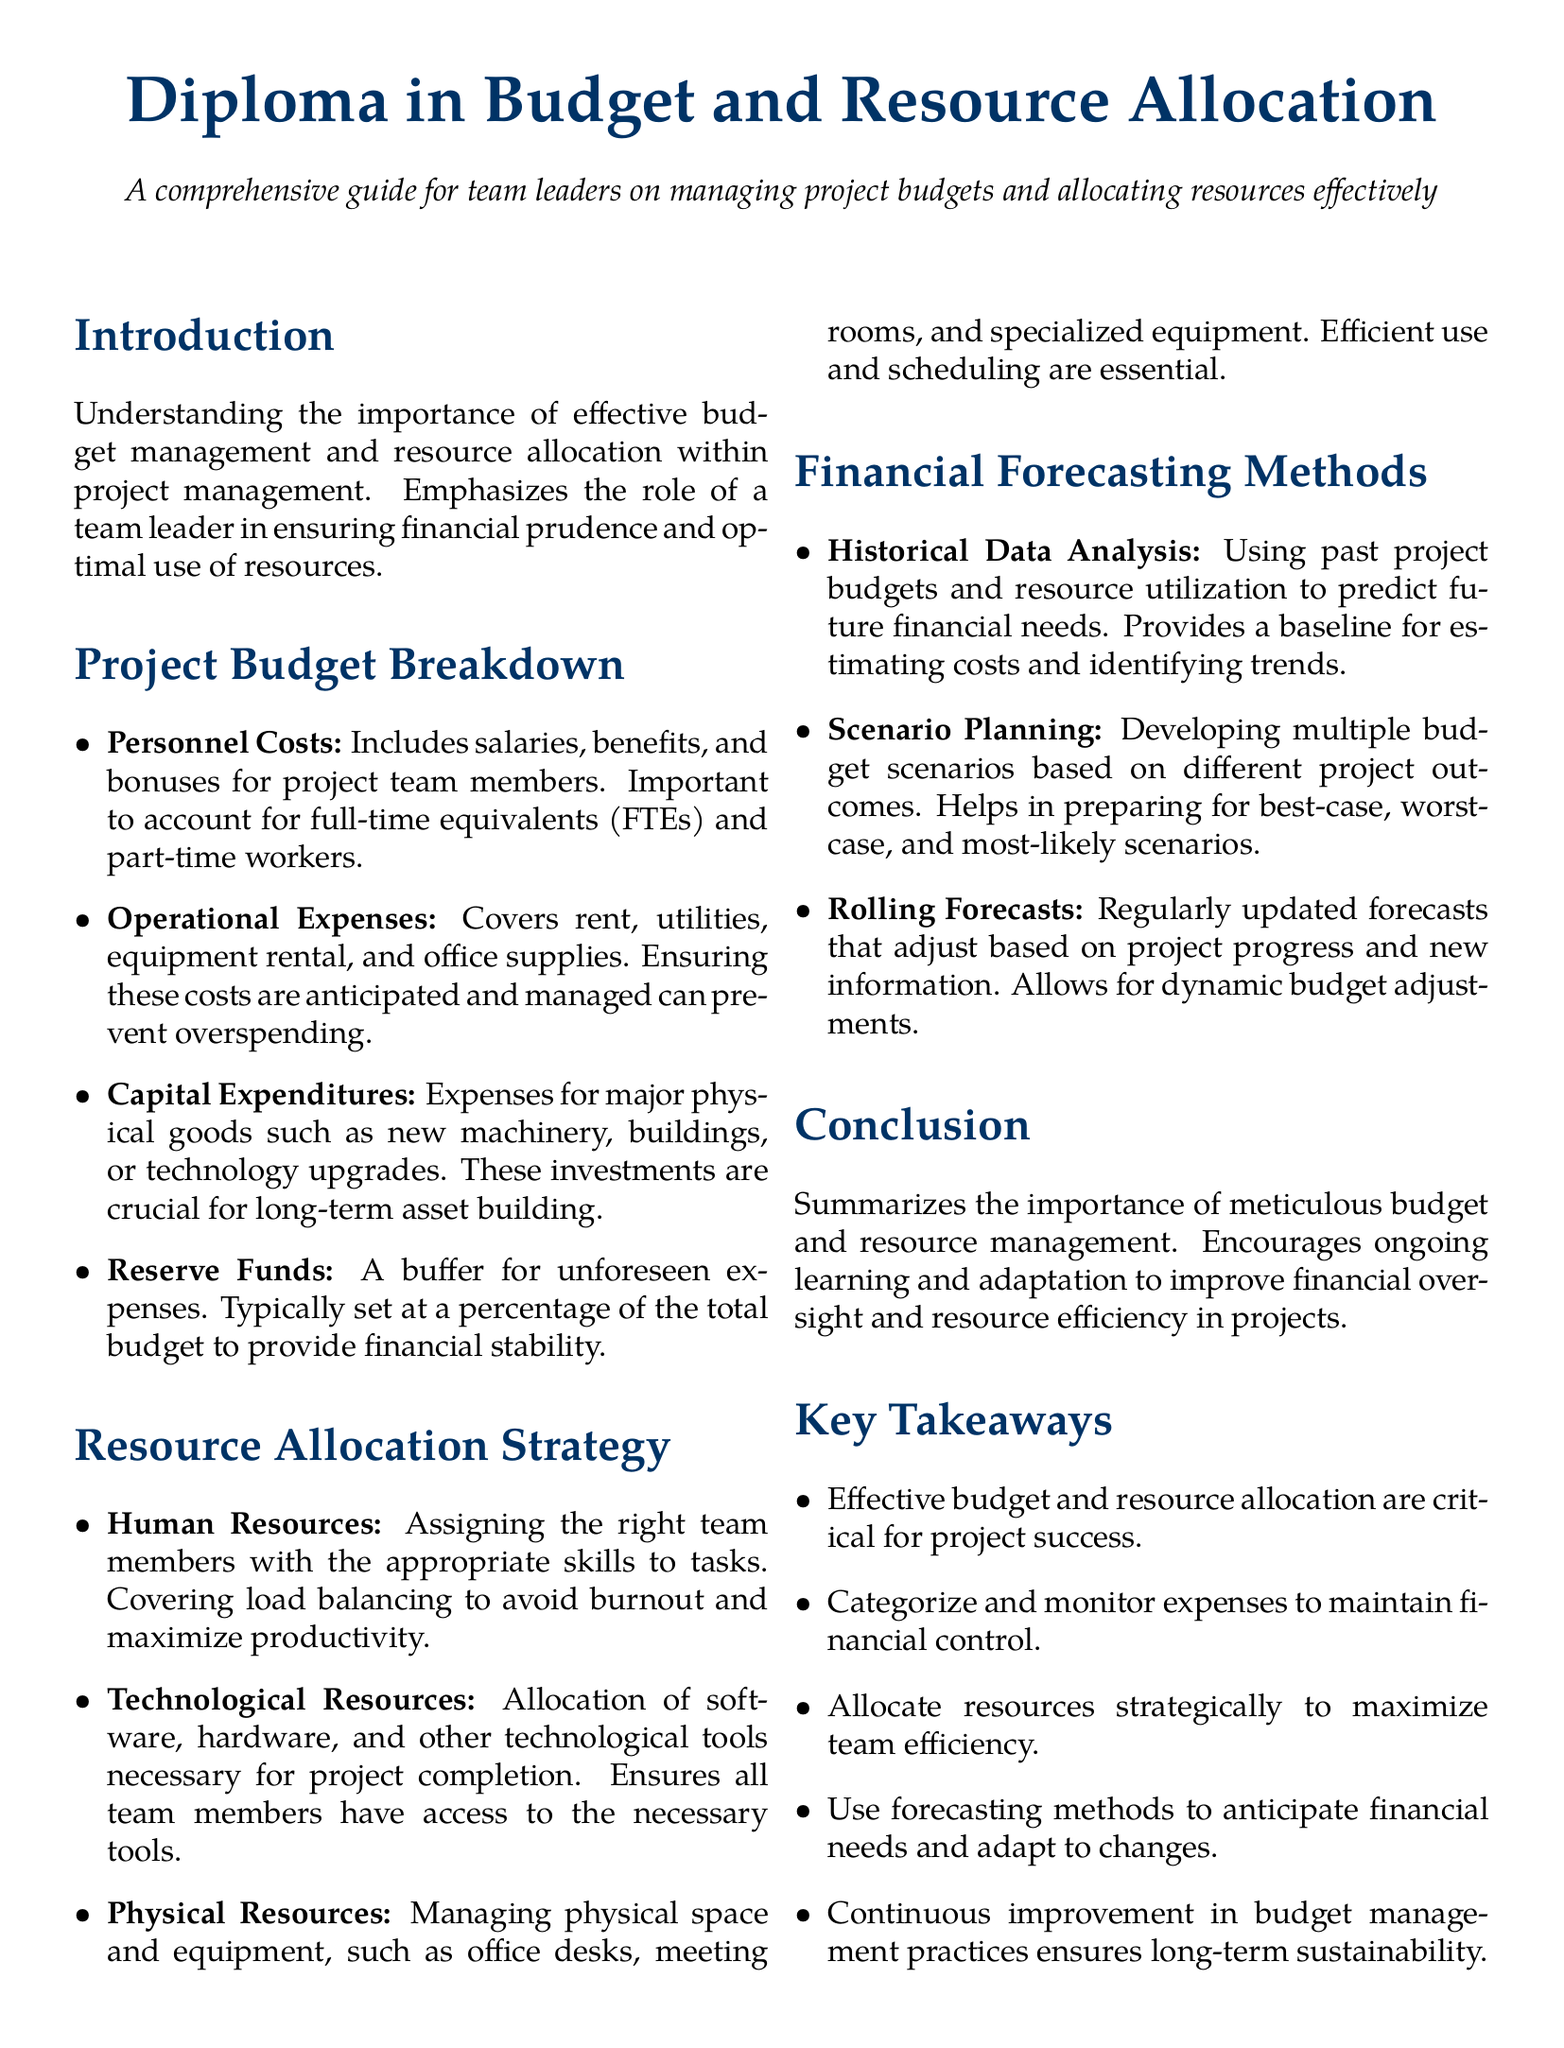What is the title of the diploma? The title of the diploma is presented prominently at the beginning of the document.
Answer: Diploma in Budget and Resource Allocation What are the main categories of expenses in the project budget? The categories of expenses in the project budget are listed in the Project Budget Breakdown section.
Answer: Personnel Costs, Operational Expenses, Capital Expenditures, Reserve Funds What does "FTE" stand for? The term "FTE" is used in the context of Personnel Costs to refer to a specific measure of full-time work.
Answer: Full-Time Equivalent What is a method mentioned for financial forecasting? The document lists various methods for financial forecasting under a dedicated section.
Answer: Historical Data Analysis What is the primary goal of resource allocation? The main goal is to ensure effective use of team capabilities and resources, as described in the Resource Allocation Strategy.
Answer: Maximize productivity What does scenario planning involve? Scenario planning as mentioned in the document involves preparing for various project outcomes.
Answer: Developing multiple budget scenarios Who is the diploma intended for? The summary at the beginning clarifies the intended audience for the diploma.
Answer: Team leaders What is a benefit of rolling forecasts? The advantages of rolling forecasts are highlighted in the Financial Forecasting Methods section.
Answer: Dynamic budget adjustments 